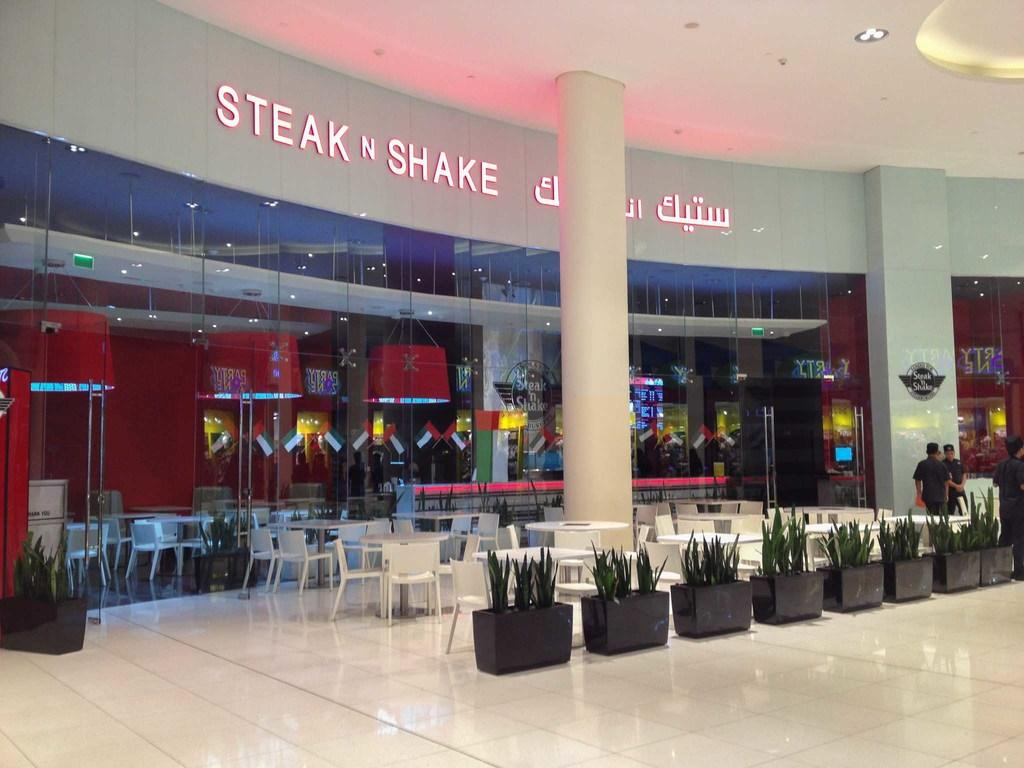<image>
Relay a brief, clear account of the picture shown. A Steak N Shake restaurant in a large open area. 